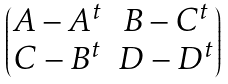Convert formula to latex. <formula><loc_0><loc_0><loc_500><loc_500>\begin{pmatrix} A - A ^ { t } & B - C ^ { t } \\ C - B ^ { t } & D - D ^ { t } \end{pmatrix}</formula> 